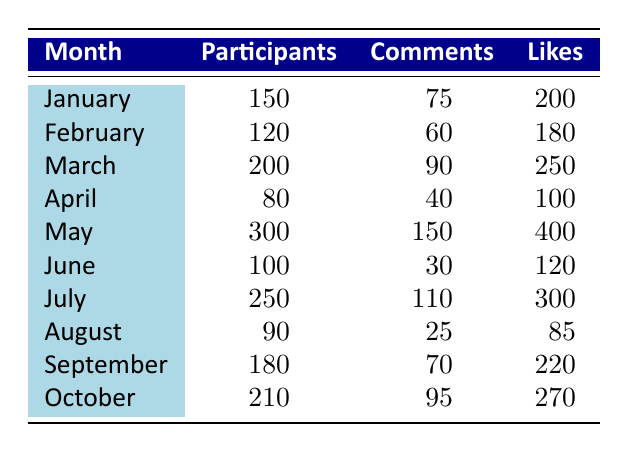What was the month with the highest number of participants? By examining the participants column, we can see that May has the highest number at 300.
Answer: May How many comments were made during the "Clerk Series Live Q&A with Creators"? Looking at the row for May, which corresponds to the event "Clerk Series Live Q&A with Creators," it shows 150 comments.
Answer: 150 Which month had the lowest number of likes? In the likes column, we can see that August has the lowest number with 85 likes.
Answer: August What was the total number of participants across all events from January to October? To find the total, we sum the participants for each month: 150 + 120 + 200 + 80 + 300 + 100 + 250 + 90 + 180 + 210 = 1,680 participants in total.
Answer: 1680 Did the "Clerk Series Trivia Night" have more likes than the "Clerk Series Fan Art Showcase"? The "Clerk Series Trivia Night" in March had 250 likes, while the "Clerk Series Fan Art Showcase" in April had 100 likes; therefore, the first event had more likes.
Answer: Yes What is the average number of comments made per event from February to October? We count the number of events from February to October (9 events) and sum the number of comments: 60 + 90 + 40 + 150 + 30 + 110 + 25 + 70 + 95 = 680 comments. The average is then calculated as 680 comments / 9 events ≈ 75.56.
Answer: Approximately 75.56 Which event had the most likes, and how many were there? The "Clerk Series Live Q&A with Creators" in May had the most likes with a total of 400.
Answer: 400 In which month was the number of participants greater than the number of likes? In June, the number of participants was 100, and the number of likes was 120, which means participants were less than likes. However, in April, 80 participants were less than 100 likes, so no month had more participants than likes in this case.
Answer: No month What was the difference in the number of comments between March and April? For March (90 comments) and April (40 comments), the difference is 90 - 40 = 50 comments.
Answer: 50 